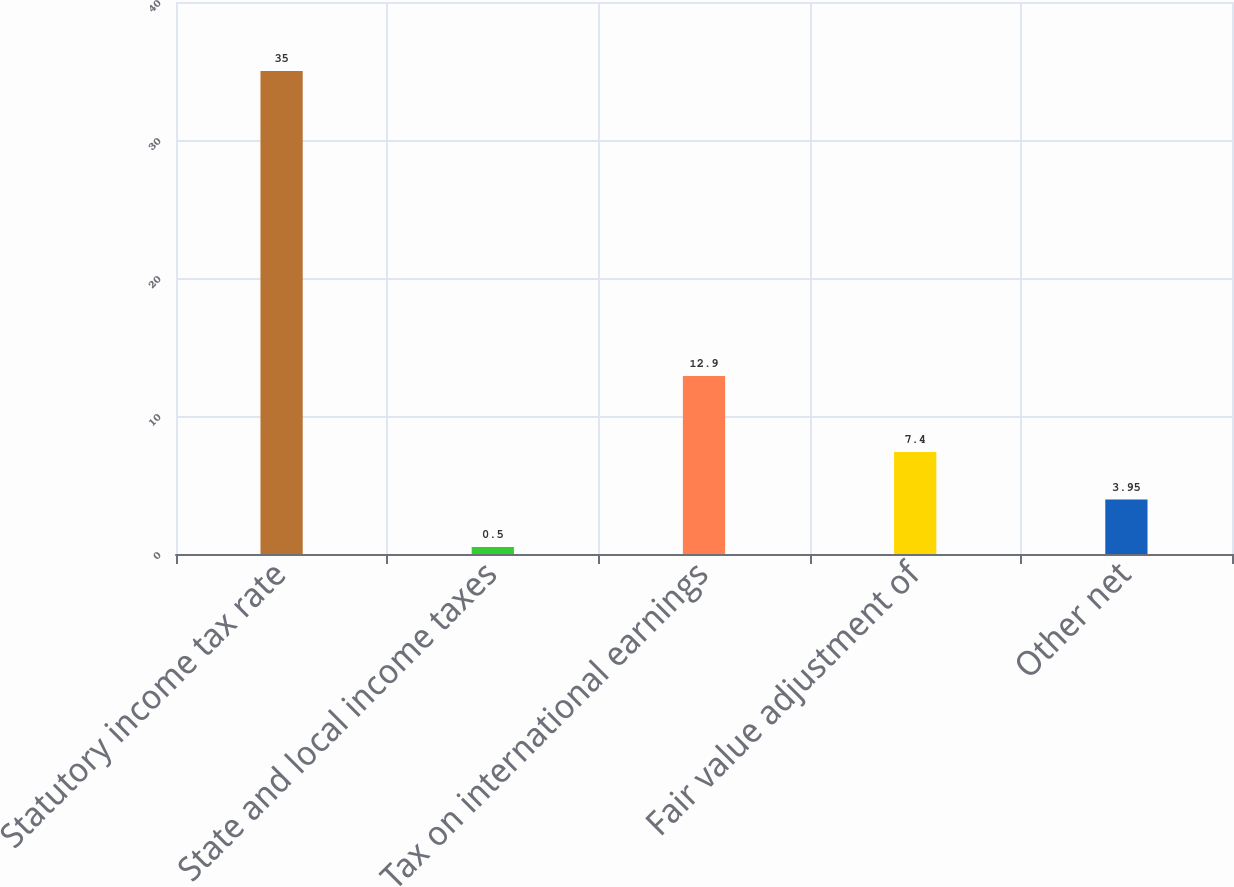<chart> <loc_0><loc_0><loc_500><loc_500><bar_chart><fcel>Statutory income tax rate<fcel>State and local income taxes<fcel>Tax on international earnings<fcel>Fair value adjustment of<fcel>Other net<nl><fcel>35<fcel>0.5<fcel>12.9<fcel>7.4<fcel>3.95<nl></chart> 